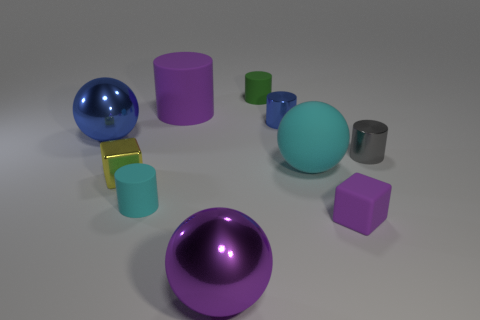Is the size of the cyan object that is to the left of the cyan matte ball the same as the gray metallic object?
Your answer should be compact. Yes. Is the number of matte cylinders to the left of the small gray object greater than the number of purple things that are to the right of the shiny cube?
Provide a short and direct response. No. What is the shape of the purple object that is in front of the yellow object and to the left of the small purple rubber block?
Offer a very short reply. Sphere. What is the shape of the small shiny object that is on the left side of the purple rubber cylinder?
Offer a very short reply. Cube. There is a purple matte thing that is to the left of the cube that is in front of the tiny metal object to the left of the small cyan cylinder; how big is it?
Your answer should be compact. Large. Do the small purple rubber object and the green rubber thing have the same shape?
Provide a succinct answer. No. There is a object that is left of the cyan matte cylinder and behind the small gray cylinder; how big is it?
Provide a succinct answer. Large. There is another object that is the same shape as the small yellow metallic object; what is it made of?
Give a very brief answer. Rubber. The large purple thing behind the purple rubber thing that is in front of the gray cylinder is made of what material?
Give a very brief answer. Rubber. There is a purple metal object; is it the same shape as the big object that is to the left of the small yellow shiny cube?
Provide a succinct answer. Yes. 